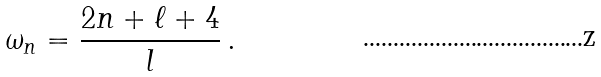<formula> <loc_0><loc_0><loc_500><loc_500>\omega _ { n } = \frac { 2 n + \ell + 4 } { l } \, .</formula> 